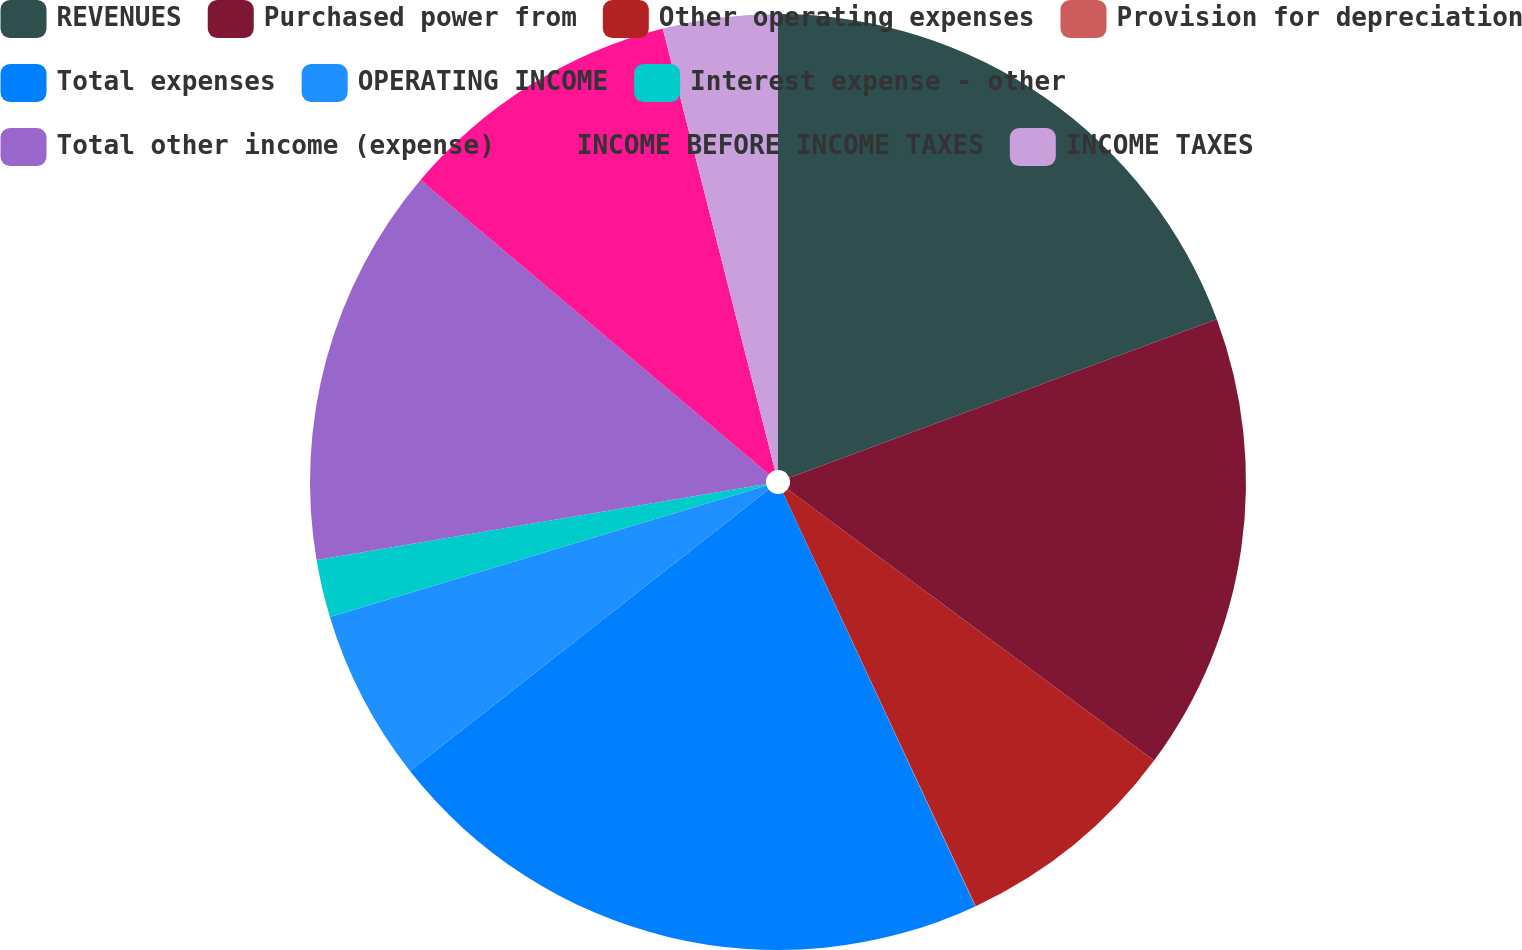Convert chart to OTSL. <chart><loc_0><loc_0><loc_500><loc_500><pie_chart><fcel>REVENUES<fcel>Purchased power from<fcel>Other operating expenses<fcel>Provision for depreciation<fcel>Total expenses<fcel>OPERATING INCOME<fcel>Interest expense - other<fcel>Total other income (expense)<fcel>INCOME BEFORE INCOME TAXES<fcel>INCOME TAXES<nl><fcel>19.35%<fcel>15.8%<fcel>7.91%<fcel>0.02%<fcel>21.33%<fcel>5.94%<fcel>1.99%<fcel>13.83%<fcel>9.88%<fcel>3.96%<nl></chart> 